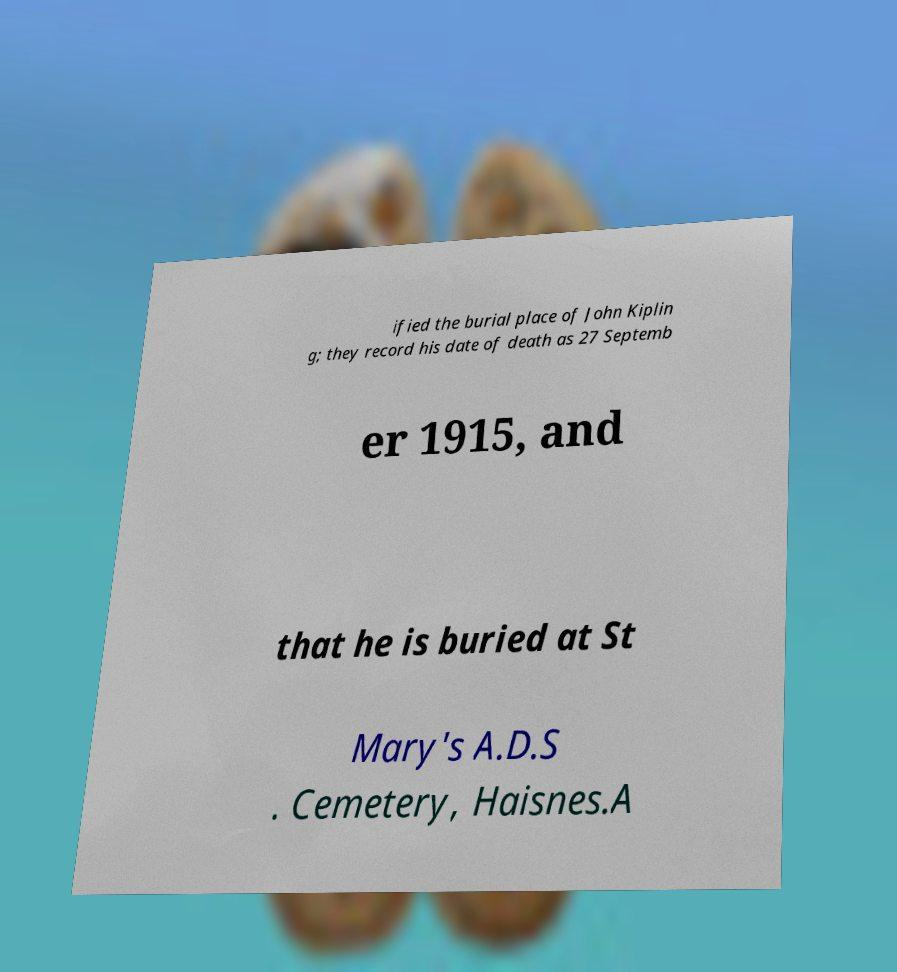Could you extract and type out the text from this image? ified the burial place of John Kiplin g; they record his date of death as 27 Septemb er 1915, and that he is buried at St Mary's A.D.S . Cemetery, Haisnes.A 